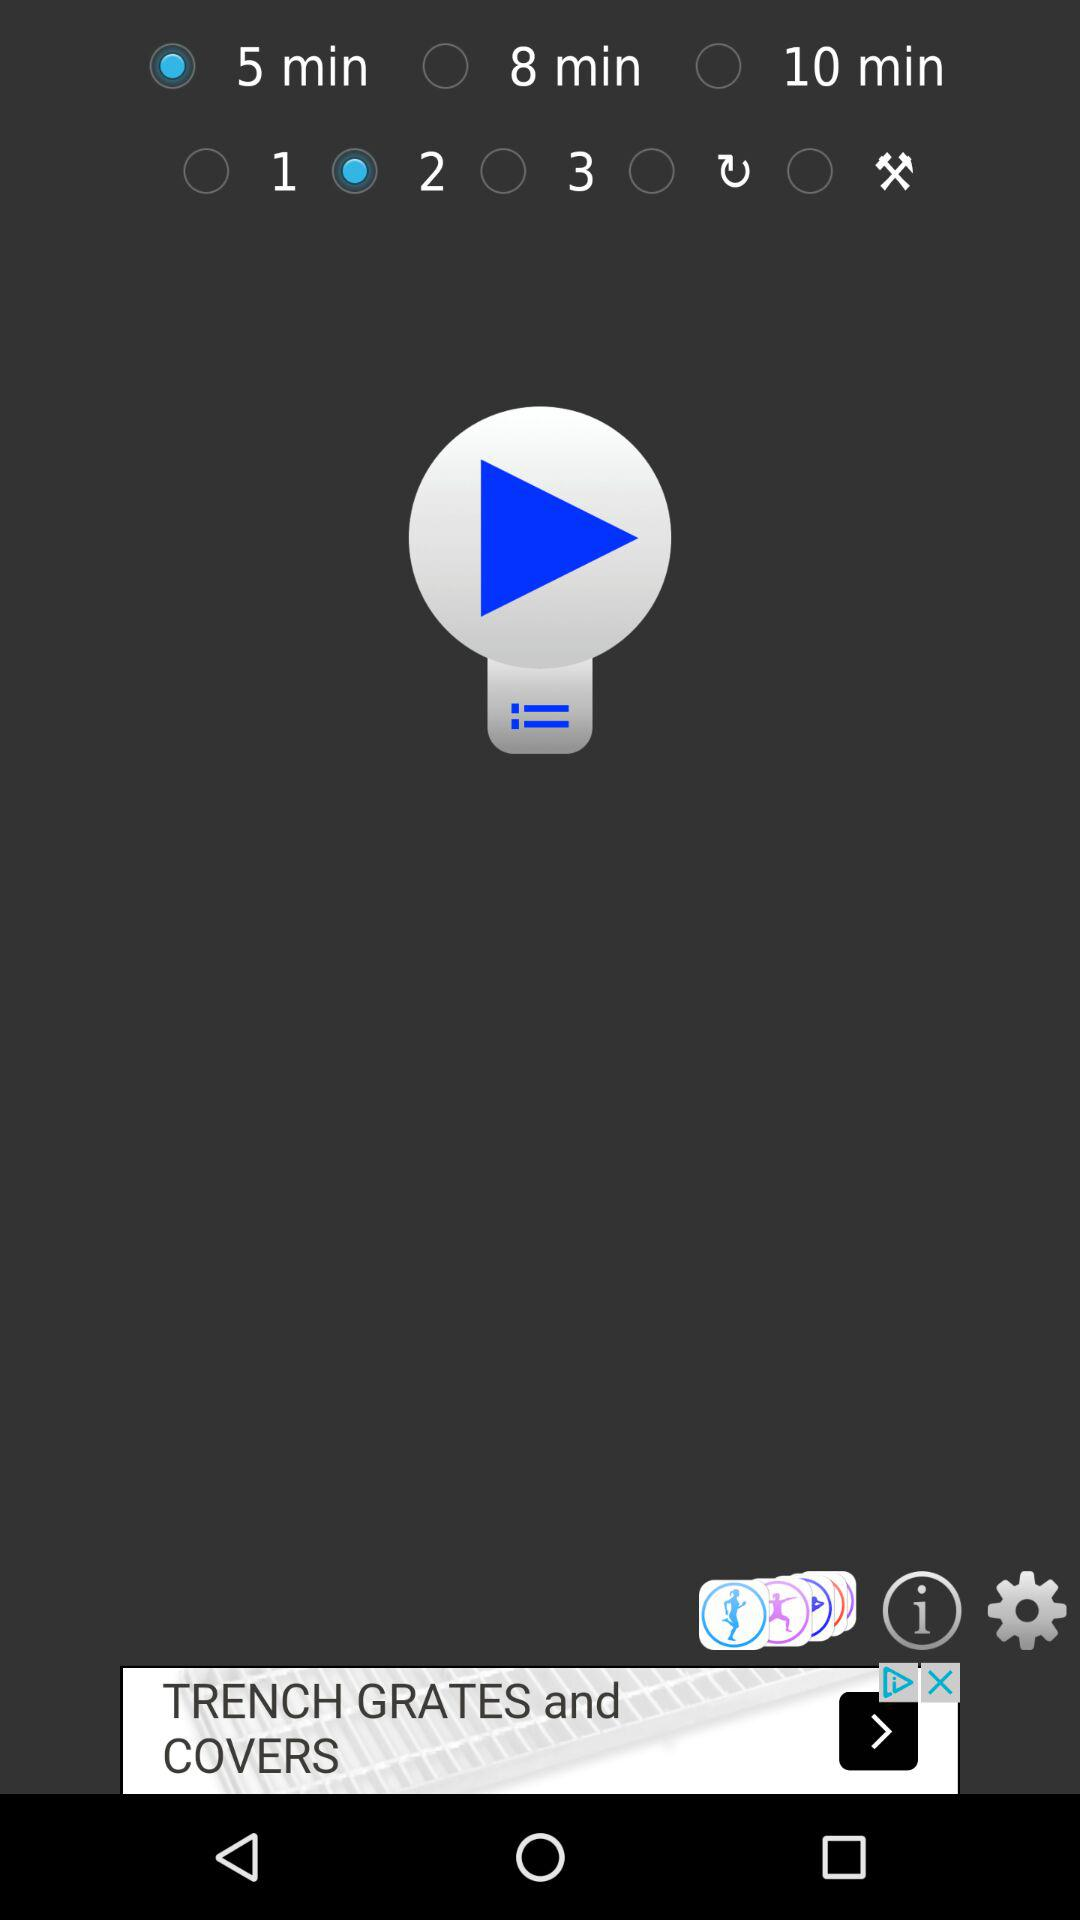What option has been selected for the time duration? The option that has been selected for the time duration is "5 min". 